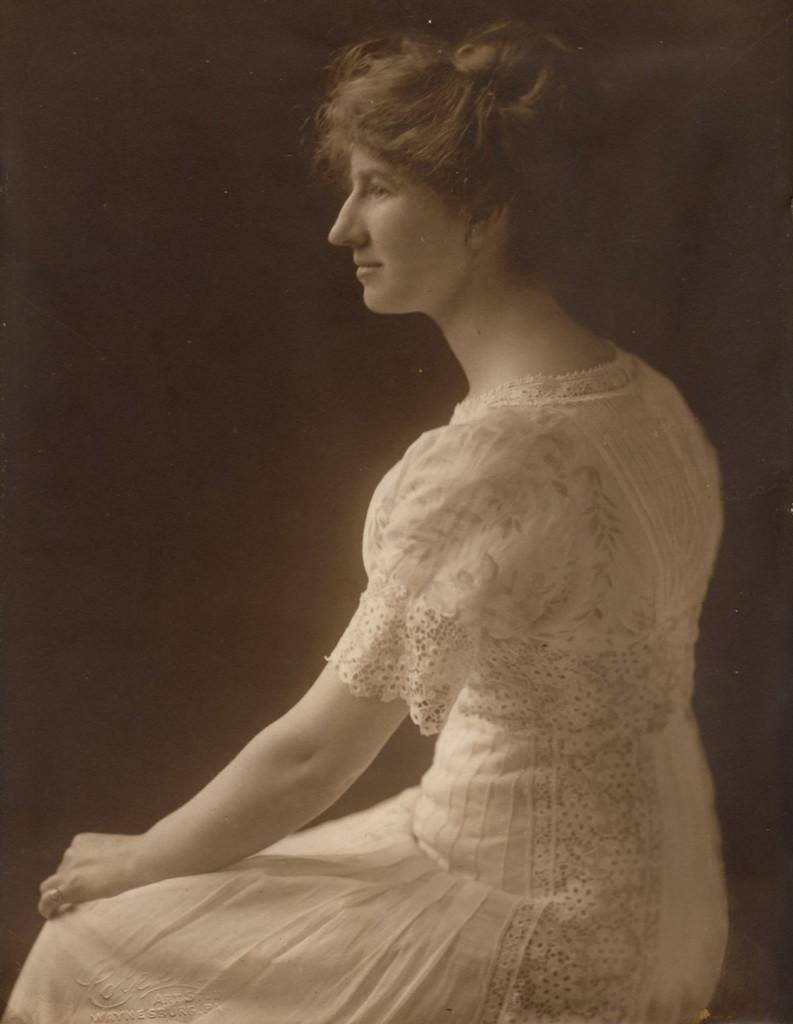What is the main subject of the image? There is a person in the image. What is the person doing in the image? The person is sitting. What is the person wearing in the image? The person is wearing a white dress. What can be observed about the background of the image? The background of the image is dark. How many cobwebs can be seen in the image? There are no cobwebs present in the image. What type of mine is depicted in the image? There is no mine present in the image. 